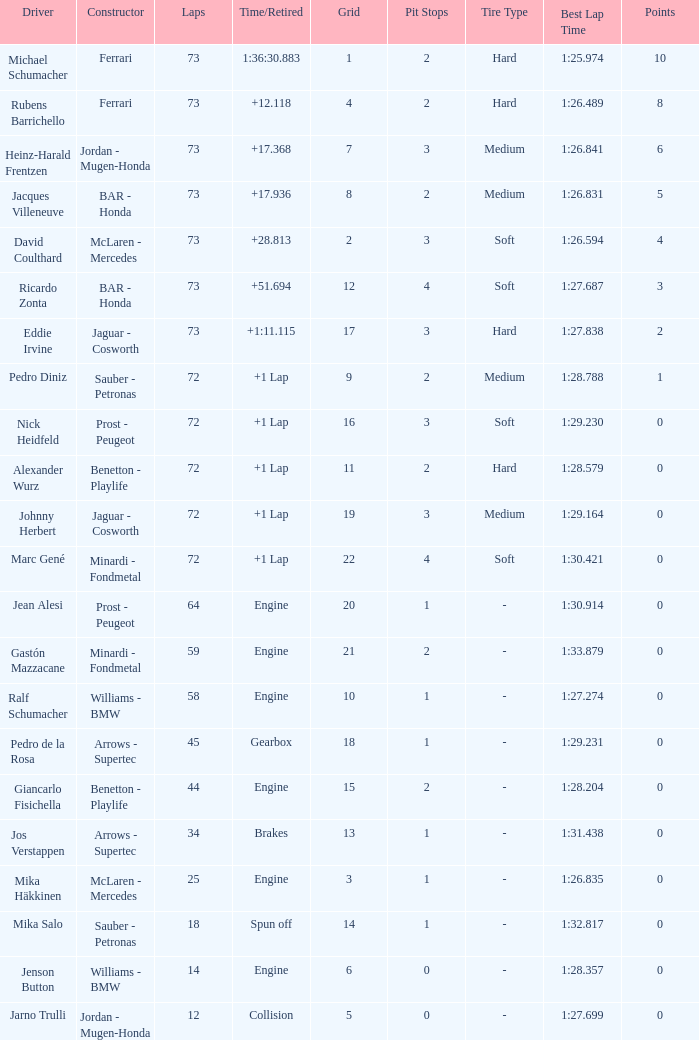How many laps did Jos Verstappen do on Grid 2? 34.0. 